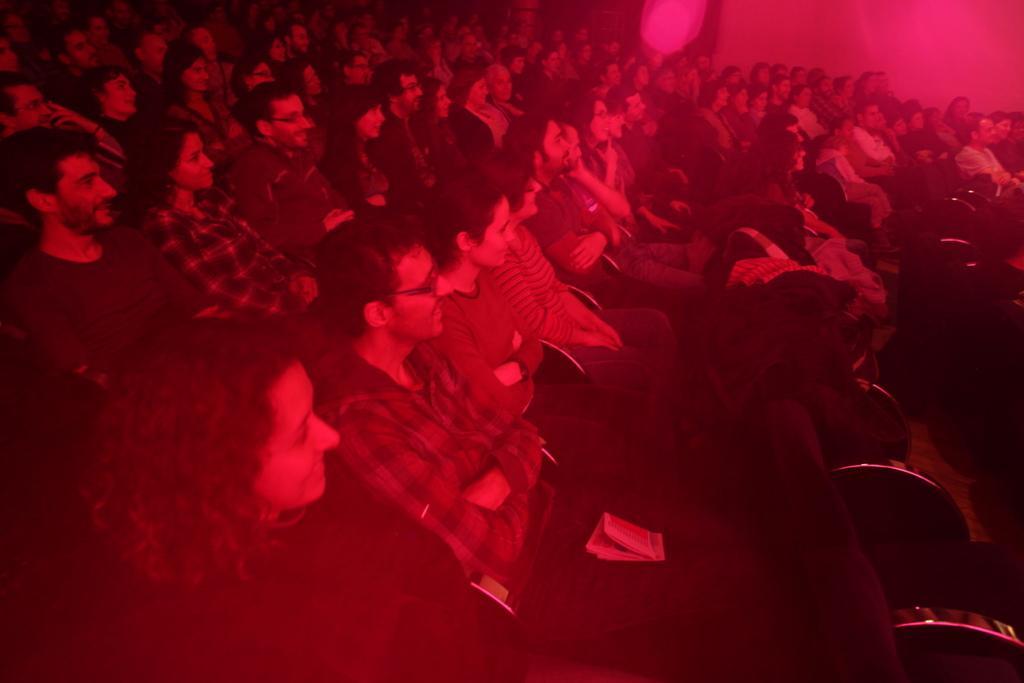Describe this image in one or two sentences. In this image we can see there are a few people sitting on the chair. 